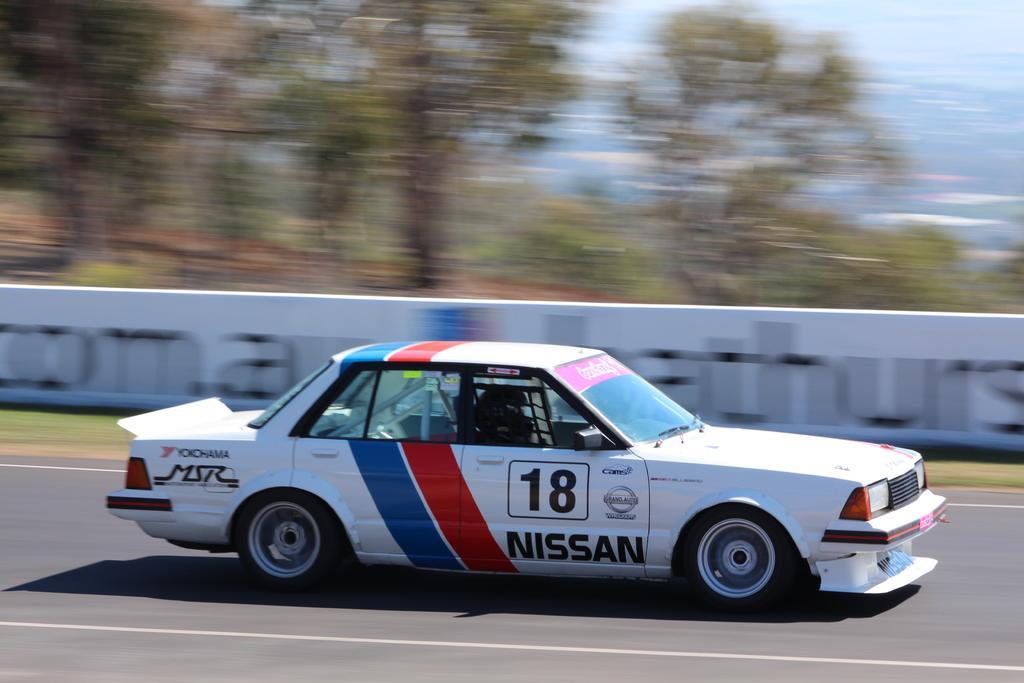Can you describe this image briefly? In this picture there is a car in the center of the image and there are trees at the top side of the image. 